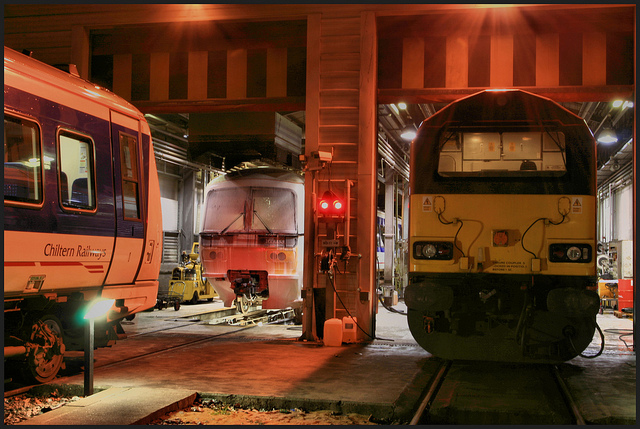<image>What is the name on the left most train? I am not sure what the name on the left most train is. It might be 'children', 'Christian', 'chiltern railways' or 'chilean railways'. What is the name on the left most train? I am not sure what is the name on the left most train. It can be seen as 'chiltern railways', 'chilean railways' or 'coltern railways'. 